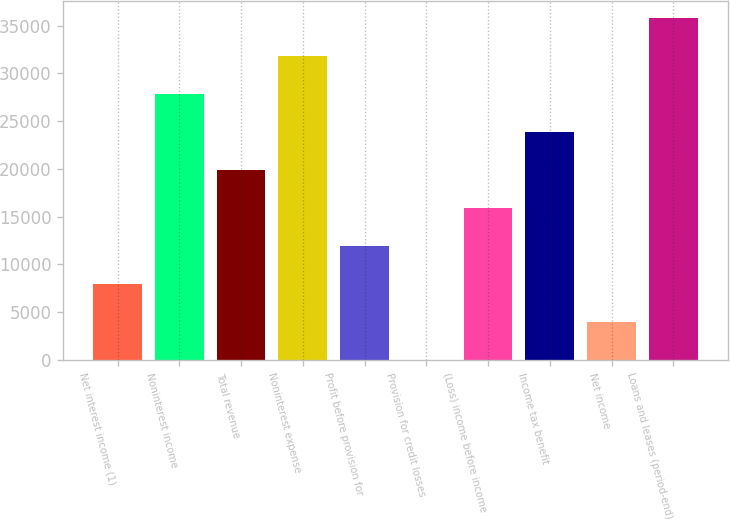Convert chart. <chart><loc_0><loc_0><loc_500><loc_500><bar_chart><fcel>Net interest income (1)<fcel>Noninterest income<fcel>Total revenue<fcel>Noninterest expense<fcel>Profit before provision for<fcel>Provision for credit losses<fcel>(Loss) income before income<fcel>Income tax benefit<fcel>Net income<fcel>Loans and leases (period-end)<nl><fcel>7958.2<fcel>27826.2<fcel>19879<fcel>31799.8<fcel>11931.8<fcel>11<fcel>15905.4<fcel>23852.6<fcel>3984.6<fcel>35773.4<nl></chart> 